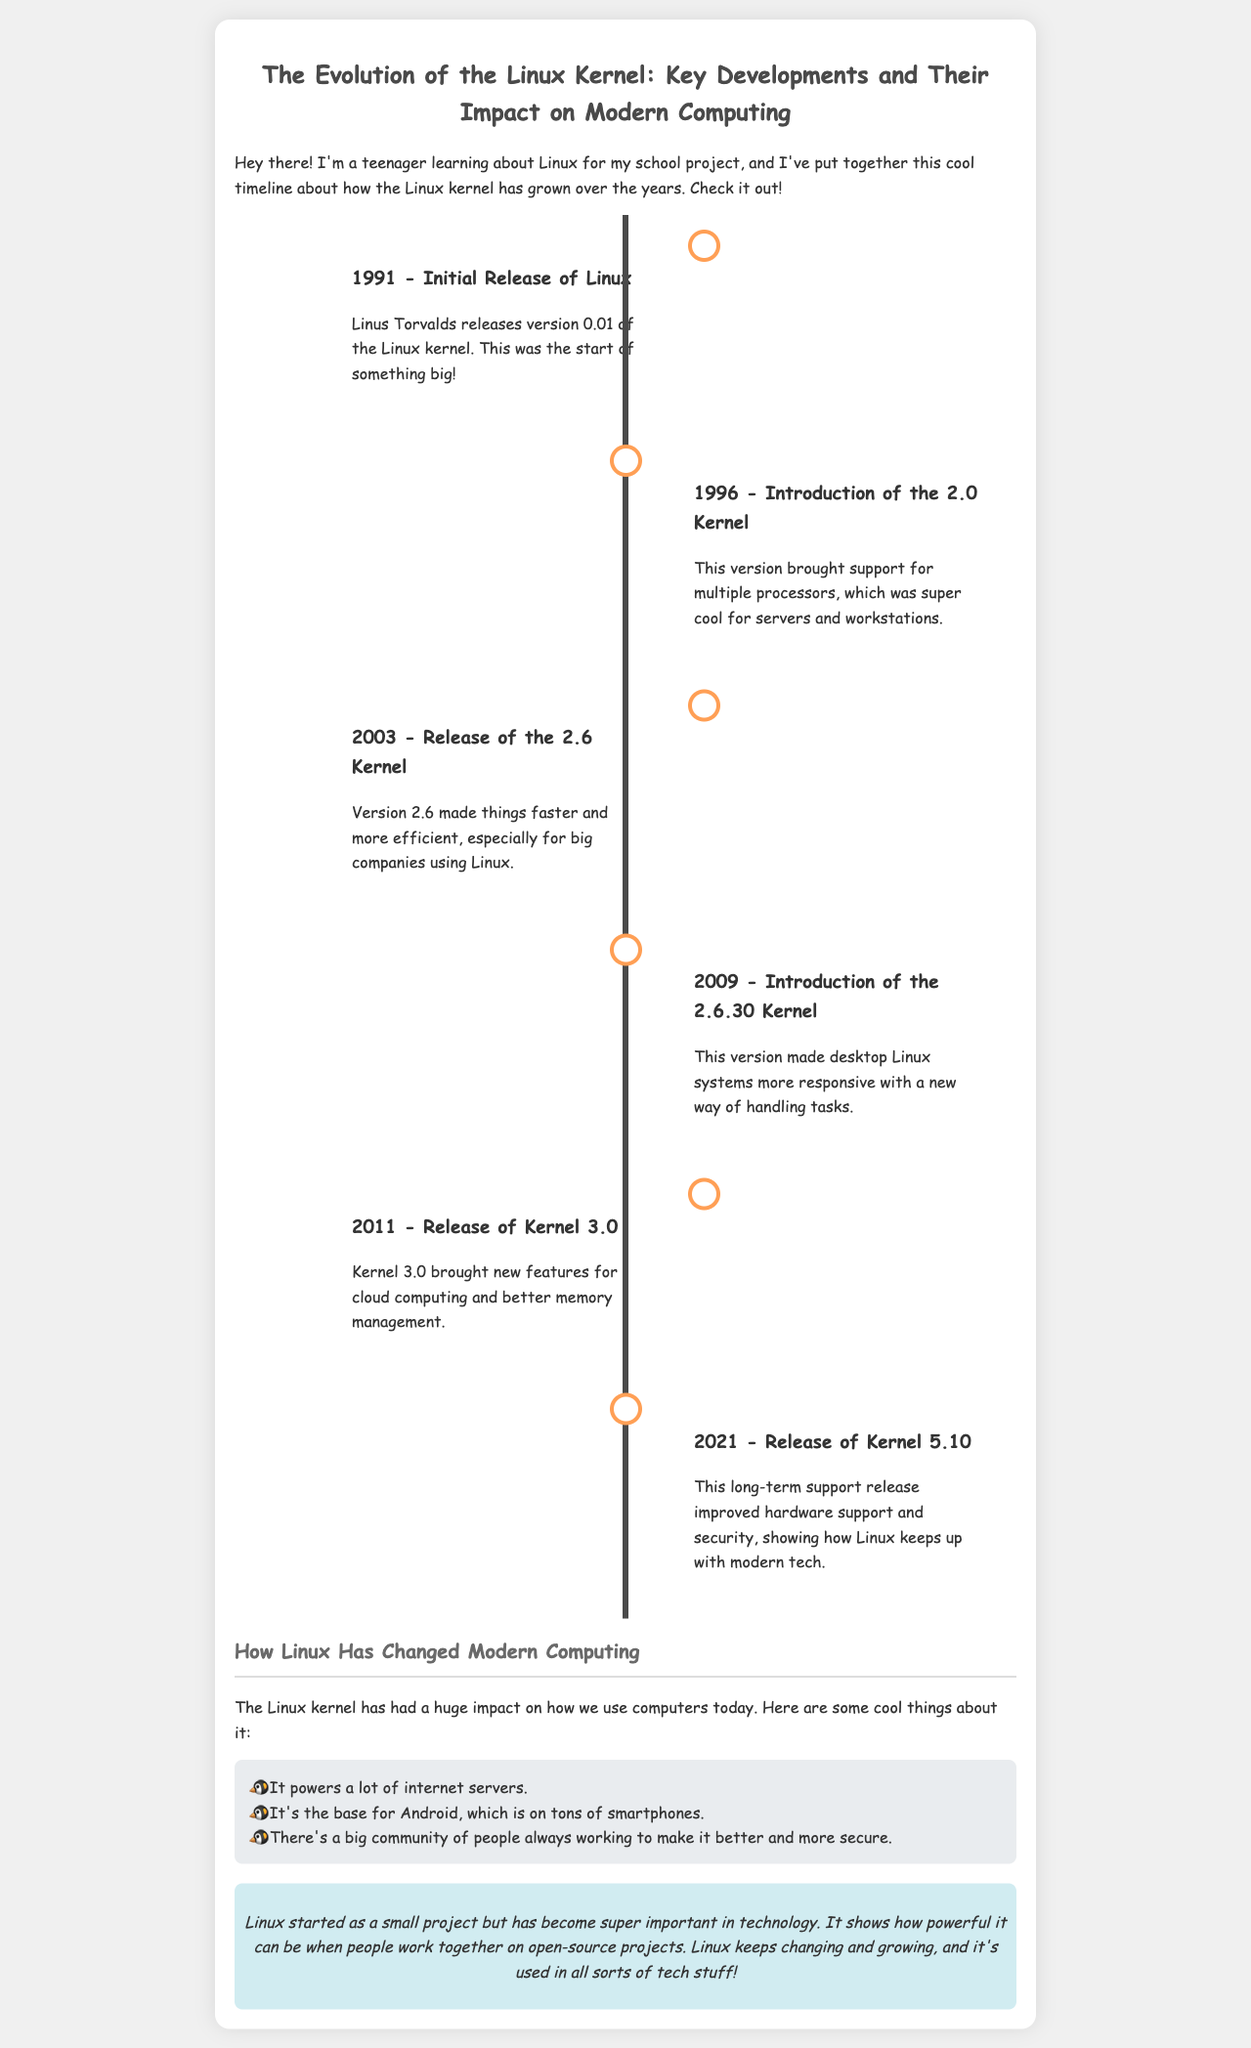what year was the initial release of Linux? The initial release of Linux occurred in 1991.
Answer: 1991 what significant feature was introduced with the 2.0 kernel? The 2.0 kernel introduced support for multiple processors.
Answer: multiple processors what version of the Linux kernel was released in 2003? The document states that version 2.6 was released in 2003.
Answer: 2.6 how did the 2.6.30 kernel improve desktop Linux systems? The 2.6.30 kernel improved responsiveness with a new way of handling tasks.
Answer: responsiveness what is one impact of the Linux kernel on modern technology? The Linux kernel powers a lot of internet servers.
Answer: internet servers why is Kernel 3.0 important for cloud computing? Kernel 3.0 brought new features for cloud computing.
Answer: new features how has Linux been significant for smartphones? Linux serves as the base for Android, which is on tons of smartphones.
Answer: Android what does the conclusion of the report highlight about open-source projects? It highlights how powerful it can be when people work together on open-source projects.
Answer: powerful how has Linux evolved in terms of security? The release of Kernel 5.10 improved hardware support and security.
Answer: hardware support and security 